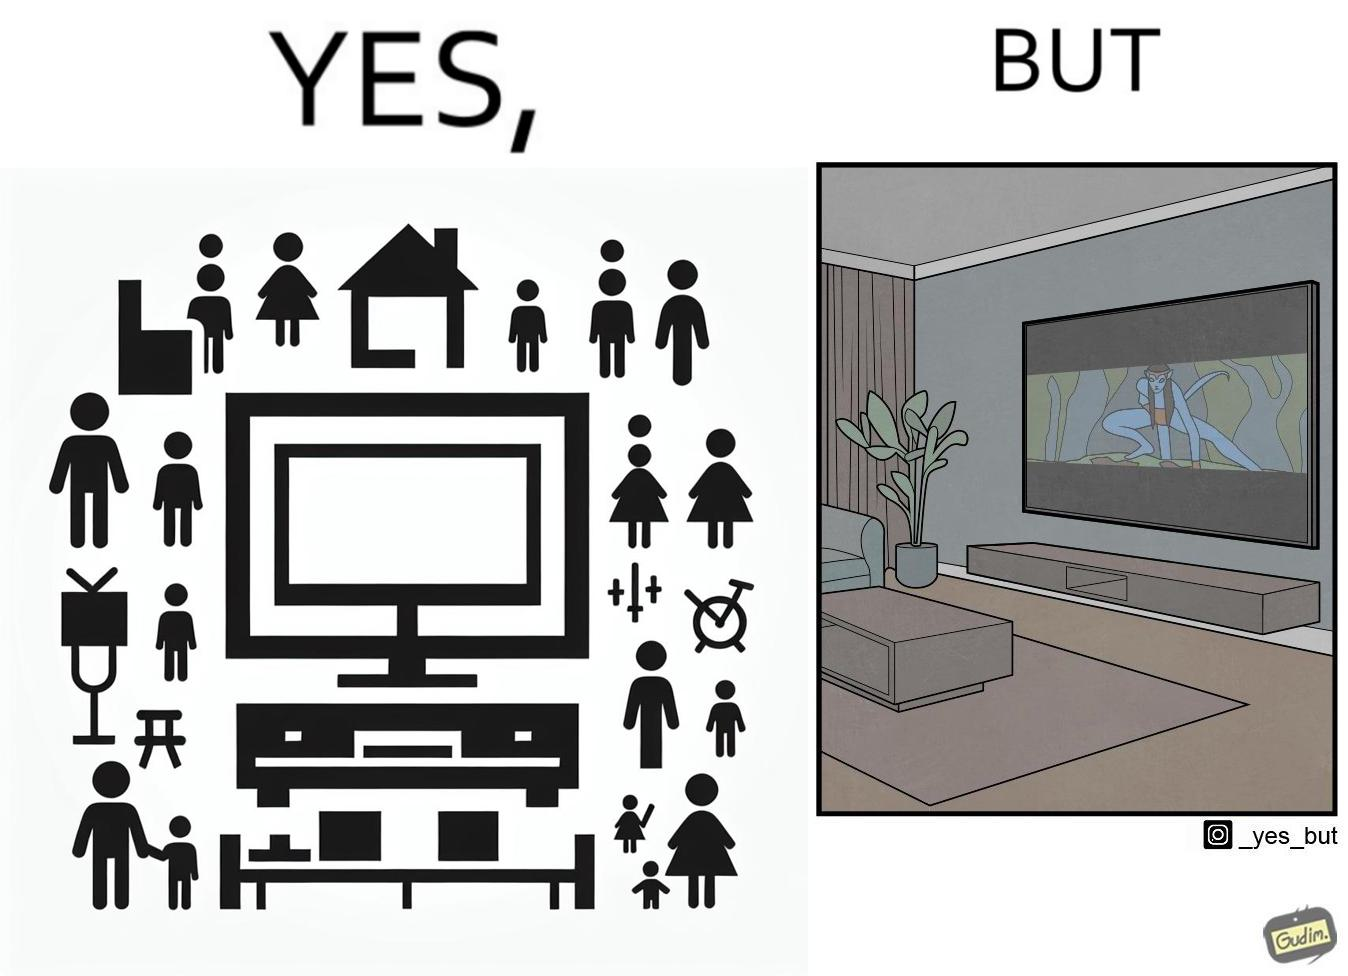What do you see in each half of this image? In the left part of the image: The image shows the living area in a home. The room has a big TV hanging on the wall. In the right part of the image: The image shows the living area in a home. The room has a big TV hanging on the wall playing a movie. The movie is not using the entire screen and top and bottom areas of the screen is unused. 